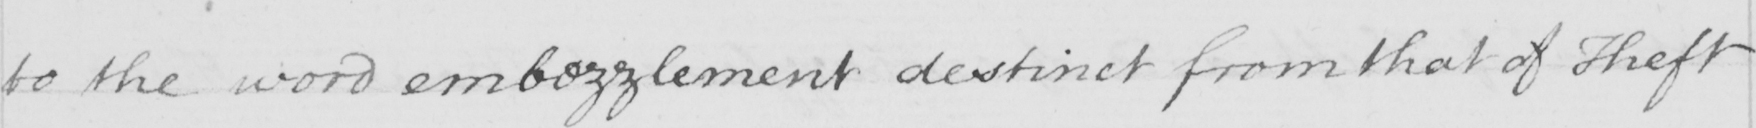What is written in this line of handwriting? to the word embezzlement destinct from that of Theft 